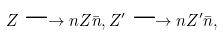<formula> <loc_0><loc_0><loc_500><loc_500>Z \longrightarrow n Z \bar { n } , Z ^ { \prime } \longrightarrow n Z ^ { \prime } \bar { n } ,</formula> 